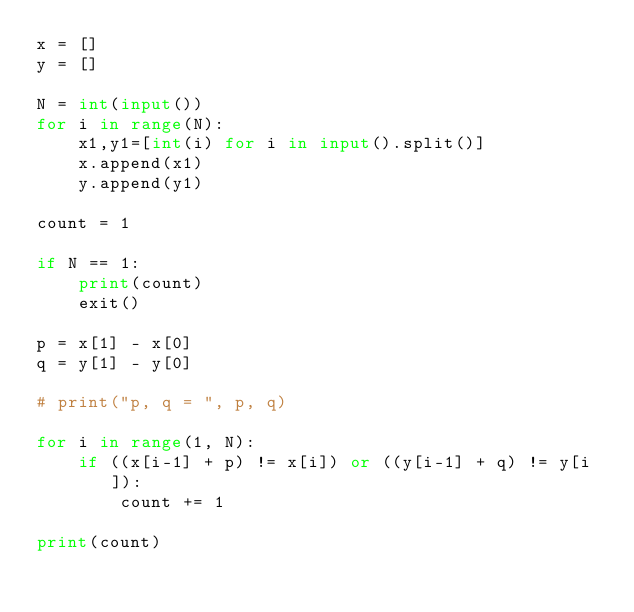Convert code to text. <code><loc_0><loc_0><loc_500><loc_500><_Python_>x = []
y = []

N = int(input())
for i in range(N):
    x1,y1=[int(i) for i in input().split()]
    x.append(x1)
    y.append(y1)

count = 1

if N == 1:
    print(count)
    exit()

p = x[1] - x[0]
q = y[1] - y[0]

# print("p, q = ", p, q)

for i in range(1, N):
    if ((x[i-1] + p) != x[i]) or ((y[i-1] + q) != y[i]):
        count += 1
        
print(count)</code> 